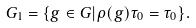Convert formula to latex. <formula><loc_0><loc_0><loc_500><loc_500>G _ { 1 } = \{ g \in G | \rho ( g ) \tau _ { 0 } = \tau _ { 0 } \} .</formula> 